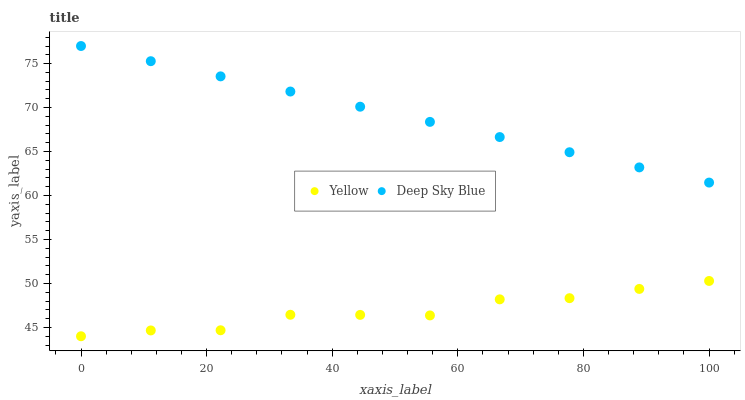Does Yellow have the minimum area under the curve?
Answer yes or no. Yes. Does Deep Sky Blue have the maximum area under the curve?
Answer yes or no. Yes. Does Yellow have the maximum area under the curve?
Answer yes or no. No. Is Deep Sky Blue the smoothest?
Answer yes or no. Yes. Is Yellow the roughest?
Answer yes or no. Yes. Is Yellow the smoothest?
Answer yes or no. No. Does Yellow have the lowest value?
Answer yes or no. Yes. Does Deep Sky Blue have the highest value?
Answer yes or no. Yes. Does Yellow have the highest value?
Answer yes or no. No. Is Yellow less than Deep Sky Blue?
Answer yes or no. Yes. Is Deep Sky Blue greater than Yellow?
Answer yes or no. Yes. Does Yellow intersect Deep Sky Blue?
Answer yes or no. No. 